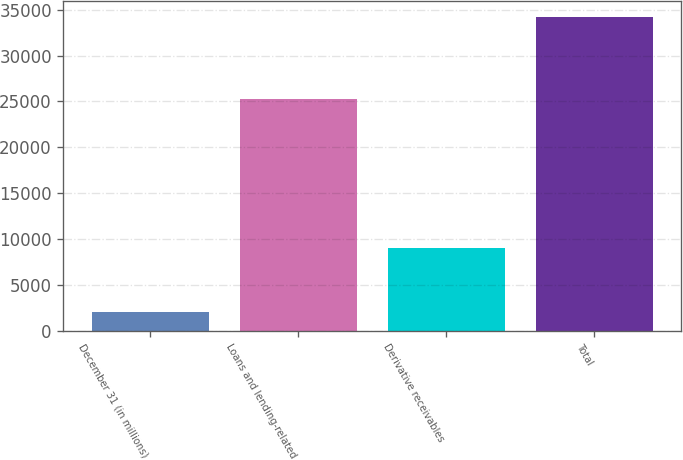Convert chart. <chart><loc_0><loc_0><loc_500><loc_500><bar_chart><fcel>December 31 (in millions)<fcel>Loans and lending-related<fcel>Derivative receivables<fcel>Total<nl><fcel>2002<fcel>25222<fcel>9040<fcel>34262<nl></chart> 